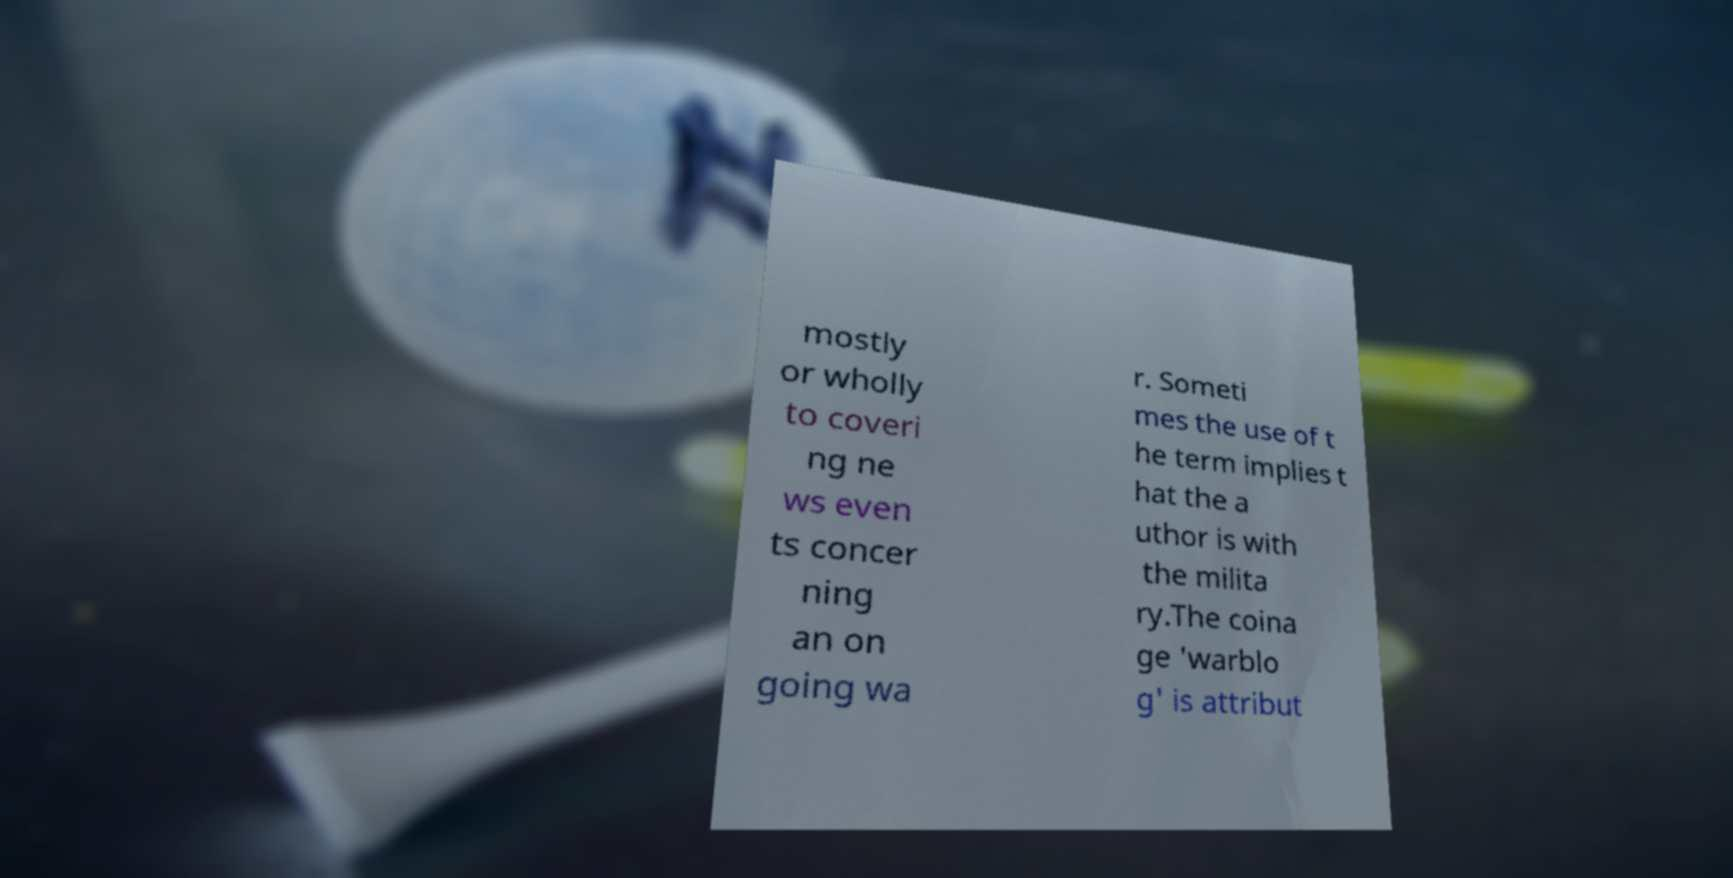There's text embedded in this image that I need extracted. Can you transcribe it verbatim? mostly or wholly to coveri ng ne ws even ts concer ning an on going wa r. Someti mes the use of t he term implies t hat the a uthor is with the milita ry.The coina ge 'warblo g' is attribut 